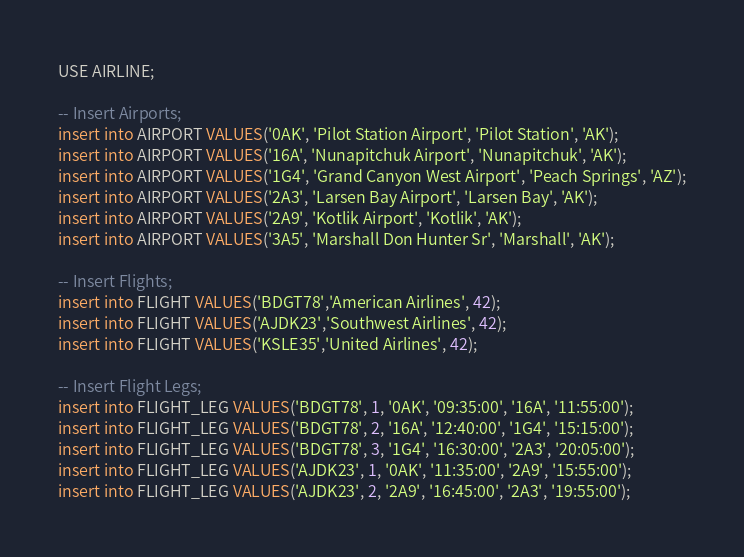Convert code to text. <code><loc_0><loc_0><loc_500><loc_500><_SQL_>USE AIRLINE;

-- Insert Airports;
insert into AIRPORT VALUES('0AK', 'Pilot Station Airport', 'Pilot Station', 'AK');
insert into AIRPORT VALUES('16A', 'Nunapitchuk Airport', 'Nunapitchuk', 'AK');
insert into AIRPORT VALUES('1G4', 'Grand Canyon West Airport', 'Peach Springs', 'AZ');
insert into AIRPORT VALUES('2A3', 'Larsen Bay Airport', 'Larsen Bay', 'AK');
insert into AIRPORT VALUES('2A9', 'Kotlik Airport', 'Kotlik', 'AK');
insert into AIRPORT VALUES('3A5', 'Marshall Don Hunter Sr', 'Marshall', 'AK');

-- Insert Flights;
insert into FLIGHT VALUES('BDGT78','American Airlines', 42);
insert into FLIGHT VALUES('AJDK23','Southwest Airlines', 42);
insert into FLIGHT VALUES('KSLE35','United Airlines', 42);

-- Insert Flight Legs;
insert into FLIGHT_LEG VALUES('BDGT78', 1, '0AK', '09:35:00', '16A', '11:55:00'); 
insert into FLIGHT_LEG VALUES('BDGT78', 2, '16A', '12:40:00', '1G4', '15:15:00'); 
insert into FLIGHT_LEG VALUES('BDGT78', 3, '1G4', '16:30:00', '2A3', '20:05:00'); 
insert into FLIGHT_LEG VALUES('AJDK23', 1, '0AK', '11:35:00', '2A9', '15:55:00'); 
insert into FLIGHT_LEG VALUES('AJDK23', 2, '2A9', '16:45:00', '2A3', '19:55:00'); 
</code> 